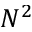<formula> <loc_0><loc_0><loc_500><loc_500>N ^ { 2 }</formula> 